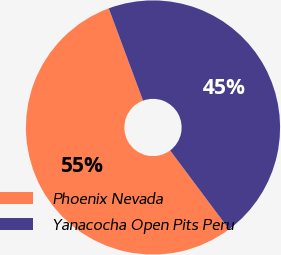<chart> <loc_0><loc_0><loc_500><loc_500><pie_chart><fcel>Phoenix Nevada<fcel>Yanacocha Open Pits Peru<nl><fcel>54.55%<fcel>45.45%<nl></chart> 